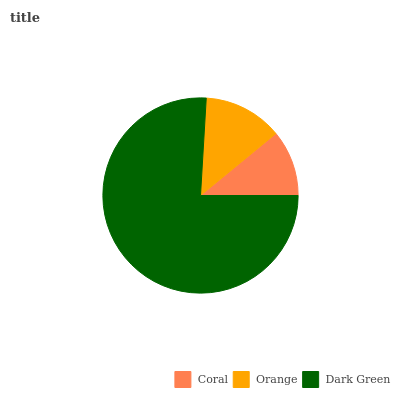Is Coral the minimum?
Answer yes or no. Yes. Is Dark Green the maximum?
Answer yes or no. Yes. Is Orange the minimum?
Answer yes or no. No. Is Orange the maximum?
Answer yes or no. No. Is Orange greater than Coral?
Answer yes or no. Yes. Is Coral less than Orange?
Answer yes or no. Yes. Is Coral greater than Orange?
Answer yes or no. No. Is Orange less than Coral?
Answer yes or no. No. Is Orange the high median?
Answer yes or no. Yes. Is Orange the low median?
Answer yes or no. Yes. Is Coral the high median?
Answer yes or no. No. Is Coral the low median?
Answer yes or no. No. 